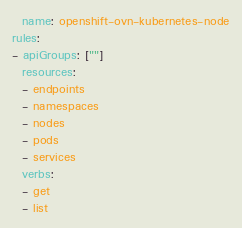<code> <loc_0><loc_0><loc_500><loc_500><_YAML_>  name: openshift-ovn-kubernetes-node
rules:
- apiGroups: [""]
  resources:
  - endpoints
  - namespaces
  - nodes
  - pods
  - services
  verbs:
  - get
  - list</code> 